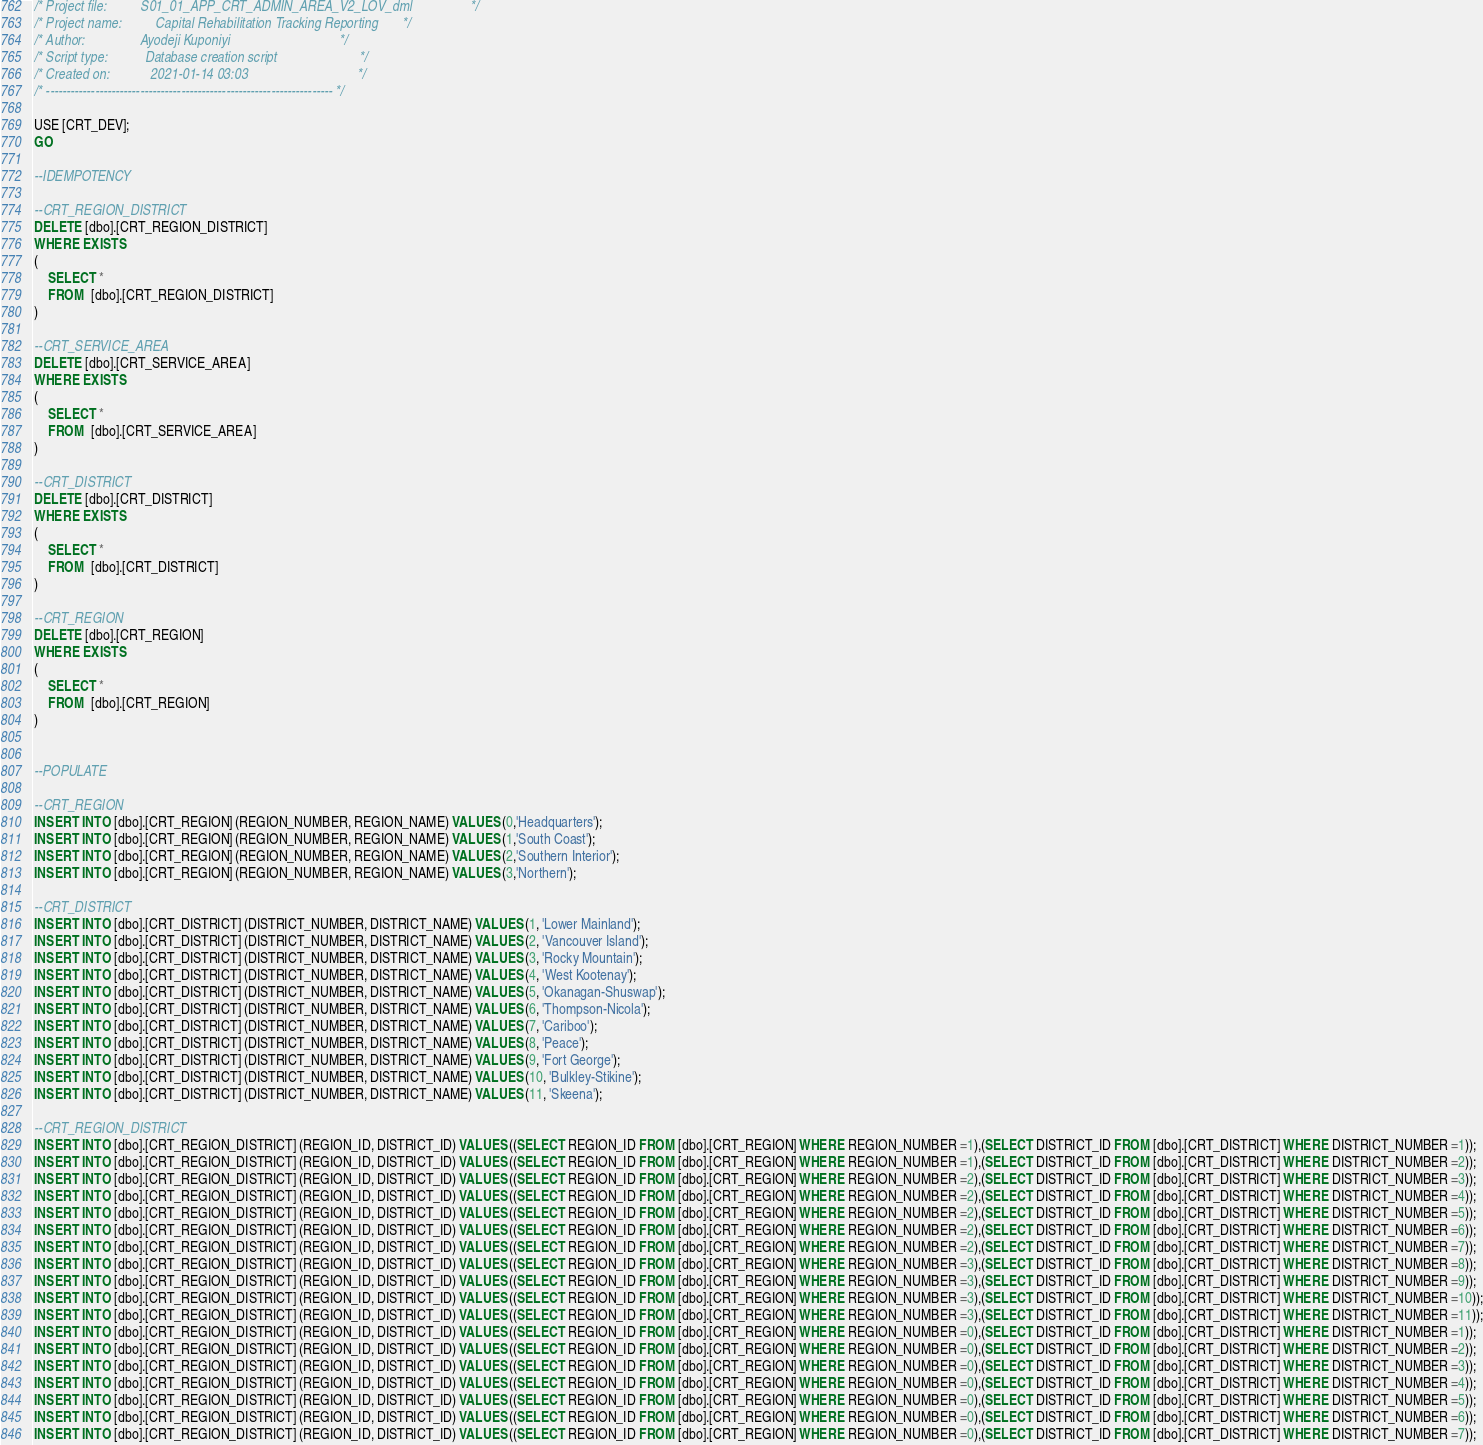Convert code to text. <code><loc_0><loc_0><loc_500><loc_500><_SQL_>/* Project file:          S01_01_APP_CRT_ADMIN_AREA_V2_LOV_dml                 */
/* Project name:          Capital Rehabilitation Tracking Reporting       */
/* Author:                Ayodeji Kuponiyi                                */
/* Script type:           Database creation script                        */
/* Created on:            2021-01-14 03:03                                */
/* ---------------------------------------------------------------------- */

USE [CRT_DEV];
GO

--IDEMPOTENCY

--CRT_REGION_DISTRICT
DELETE [dbo].[CRT_REGION_DISTRICT]
WHERE EXISTS
(
	SELECT *
	FROM  [dbo].[CRT_REGION_DISTRICT] 
)

--CRT_SERVICE_AREA
DELETE [dbo].[CRT_SERVICE_AREA]
WHERE EXISTS
(
	SELECT *
	FROM  [dbo].[CRT_SERVICE_AREA] 
)

--CRT_DISTRICT
DELETE [dbo].[CRT_DISTRICT]
WHERE EXISTS
(
	SELECT *
	FROM  [dbo].[CRT_DISTRICT] 
)

--CRT_REGION
DELETE [dbo].[CRT_REGION]
WHERE EXISTS
(
	SELECT *
	FROM  [dbo].[CRT_REGION] 
)


--POPULATE

--CRT_REGION
INSERT INTO [dbo].[CRT_REGION] (REGION_NUMBER, REGION_NAME) VALUES (0,'Headquarters');
INSERT INTO [dbo].[CRT_REGION] (REGION_NUMBER, REGION_NAME) VALUES (1,'South Coast');
INSERT INTO [dbo].[CRT_REGION] (REGION_NUMBER, REGION_NAME) VALUES (2,'Southern Interior');
INSERT INTO [dbo].[CRT_REGION] (REGION_NUMBER, REGION_NAME) VALUES (3,'Northern');

--CRT_DISTRICT
INSERT INTO [dbo].[CRT_DISTRICT] (DISTRICT_NUMBER, DISTRICT_NAME) VALUES (1, 'Lower Mainland');
INSERT INTO [dbo].[CRT_DISTRICT] (DISTRICT_NUMBER, DISTRICT_NAME) VALUES (2, 'Vancouver Island');
INSERT INTO [dbo].[CRT_DISTRICT] (DISTRICT_NUMBER, DISTRICT_NAME) VALUES (3, 'Rocky Mountain');
INSERT INTO [dbo].[CRT_DISTRICT] (DISTRICT_NUMBER, DISTRICT_NAME) VALUES (4, 'West Kootenay');
INSERT INTO [dbo].[CRT_DISTRICT] (DISTRICT_NUMBER, DISTRICT_NAME) VALUES (5, 'Okanagan-Shuswap');
INSERT INTO [dbo].[CRT_DISTRICT] (DISTRICT_NUMBER, DISTRICT_NAME) VALUES (6, 'Thompson-Nicola');
INSERT INTO [dbo].[CRT_DISTRICT] (DISTRICT_NUMBER, DISTRICT_NAME) VALUES (7, 'Cariboo');
INSERT INTO [dbo].[CRT_DISTRICT] (DISTRICT_NUMBER, DISTRICT_NAME) VALUES (8, 'Peace');
INSERT INTO [dbo].[CRT_DISTRICT] (DISTRICT_NUMBER, DISTRICT_NAME) VALUES (9, 'Fort George');
INSERT INTO [dbo].[CRT_DISTRICT] (DISTRICT_NUMBER, DISTRICT_NAME) VALUES (10, 'Bulkley-Stikine');
INSERT INTO [dbo].[CRT_DISTRICT] (DISTRICT_NUMBER, DISTRICT_NAME) VALUES (11, 'Skeena');

--CRT_REGION_DISTRICT
INSERT INTO [dbo].[CRT_REGION_DISTRICT] (REGION_ID, DISTRICT_ID) VALUES ((SELECT REGION_ID FROM [dbo].[CRT_REGION] WHERE REGION_NUMBER =1),(SELECT DISTRICT_ID FROM [dbo].[CRT_DISTRICT] WHERE DISTRICT_NUMBER =1));
INSERT INTO [dbo].[CRT_REGION_DISTRICT] (REGION_ID, DISTRICT_ID) VALUES ((SELECT REGION_ID FROM [dbo].[CRT_REGION] WHERE REGION_NUMBER =1),(SELECT DISTRICT_ID FROM [dbo].[CRT_DISTRICT] WHERE DISTRICT_NUMBER =2));
INSERT INTO [dbo].[CRT_REGION_DISTRICT] (REGION_ID, DISTRICT_ID) VALUES ((SELECT REGION_ID FROM [dbo].[CRT_REGION] WHERE REGION_NUMBER =2),(SELECT DISTRICT_ID FROM [dbo].[CRT_DISTRICT] WHERE DISTRICT_NUMBER =3));
INSERT INTO [dbo].[CRT_REGION_DISTRICT] (REGION_ID, DISTRICT_ID) VALUES ((SELECT REGION_ID FROM [dbo].[CRT_REGION] WHERE REGION_NUMBER =2),(SELECT DISTRICT_ID FROM [dbo].[CRT_DISTRICT] WHERE DISTRICT_NUMBER =4));
INSERT INTO [dbo].[CRT_REGION_DISTRICT] (REGION_ID, DISTRICT_ID) VALUES ((SELECT REGION_ID FROM [dbo].[CRT_REGION] WHERE REGION_NUMBER =2),(SELECT DISTRICT_ID FROM [dbo].[CRT_DISTRICT] WHERE DISTRICT_NUMBER =5));
INSERT INTO [dbo].[CRT_REGION_DISTRICT] (REGION_ID, DISTRICT_ID) VALUES ((SELECT REGION_ID FROM [dbo].[CRT_REGION] WHERE REGION_NUMBER =2),(SELECT DISTRICT_ID FROM [dbo].[CRT_DISTRICT] WHERE DISTRICT_NUMBER =6));
INSERT INTO [dbo].[CRT_REGION_DISTRICT] (REGION_ID, DISTRICT_ID) VALUES ((SELECT REGION_ID FROM [dbo].[CRT_REGION] WHERE REGION_NUMBER =2),(SELECT DISTRICT_ID FROM [dbo].[CRT_DISTRICT] WHERE DISTRICT_NUMBER =7));
INSERT INTO [dbo].[CRT_REGION_DISTRICT] (REGION_ID, DISTRICT_ID) VALUES ((SELECT REGION_ID FROM [dbo].[CRT_REGION] WHERE REGION_NUMBER =3),(SELECT DISTRICT_ID FROM [dbo].[CRT_DISTRICT] WHERE DISTRICT_NUMBER =8));
INSERT INTO [dbo].[CRT_REGION_DISTRICT] (REGION_ID, DISTRICT_ID) VALUES ((SELECT REGION_ID FROM [dbo].[CRT_REGION] WHERE REGION_NUMBER =3),(SELECT DISTRICT_ID FROM [dbo].[CRT_DISTRICT] WHERE DISTRICT_NUMBER =9));
INSERT INTO [dbo].[CRT_REGION_DISTRICT] (REGION_ID, DISTRICT_ID) VALUES ((SELECT REGION_ID FROM [dbo].[CRT_REGION] WHERE REGION_NUMBER =3),(SELECT DISTRICT_ID FROM [dbo].[CRT_DISTRICT] WHERE DISTRICT_NUMBER =10));
INSERT INTO [dbo].[CRT_REGION_DISTRICT] (REGION_ID, DISTRICT_ID) VALUES ((SELECT REGION_ID FROM [dbo].[CRT_REGION] WHERE REGION_NUMBER =3),(SELECT DISTRICT_ID FROM [dbo].[CRT_DISTRICT] WHERE DISTRICT_NUMBER =11));
INSERT INTO [dbo].[CRT_REGION_DISTRICT] (REGION_ID, DISTRICT_ID) VALUES ((SELECT REGION_ID FROM [dbo].[CRT_REGION] WHERE REGION_NUMBER =0),(SELECT DISTRICT_ID FROM [dbo].[CRT_DISTRICT] WHERE DISTRICT_NUMBER =1));
INSERT INTO [dbo].[CRT_REGION_DISTRICT] (REGION_ID, DISTRICT_ID) VALUES ((SELECT REGION_ID FROM [dbo].[CRT_REGION] WHERE REGION_NUMBER =0),(SELECT DISTRICT_ID FROM [dbo].[CRT_DISTRICT] WHERE DISTRICT_NUMBER =2));
INSERT INTO [dbo].[CRT_REGION_DISTRICT] (REGION_ID, DISTRICT_ID) VALUES ((SELECT REGION_ID FROM [dbo].[CRT_REGION] WHERE REGION_NUMBER =0),(SELECT DISTRICT_ID FROM [dbo].[CRT_DISTRICT] WHERE DISTRICT_NUMBER =3));
INSERT INTO [dbo].[CRT_REGION_DISTRICT] (REGION_ID, DISTRICT_ID) VALUES ((SELECT REGION_ID FROM [dbo].[CRT_REGION] WHERE REGION_NUMBER =0),(SELECT DISTRICT_ID FROM [dbo].[CRT_DISTRICT] WHERE DISTRICT_NUMBER =4));
INSERT INTO [dbo].[CRT_REGION_DISTRICT] (REGION_ID, DISTRICT_ID) VALUES ((SELECT REGION_ID FROM [dbo].[CRT_REGION] WHERE REGION_NUMBER =0),(SELECT DISTRICT_ID FROM [dbo].[CRT_DISTRICT] WHERE DISTRICT_NUMBER =5));
INSERT INTO [dbo].[CRT_REGION_DISTRICT] (REGION_ID, DISTRICT_ID) VALUES ((SELECT REGION_ID FROM [dbo].[CRT_REGION] WHERE REGION_NUMBER =0),(SELECT DISTRICT_ID FROM [dbo].[CRT_DISTRICT] WHERE DISTRICT_NUMBER =6));
INSERT INTO [dbo].[CRT_REGION_DISTRICT] (REGION_ID, DISTRICT_ID) VALUES ((SELECT REGION_ID FROM [dbo].[CRT_REGION] WHERE REGION_NUMBER =0),(SELECT DISTRICT_ID FROM [dbo].[CRT_DISTRICT] WHERE DISTRICT_NUMBER =7));</code> 